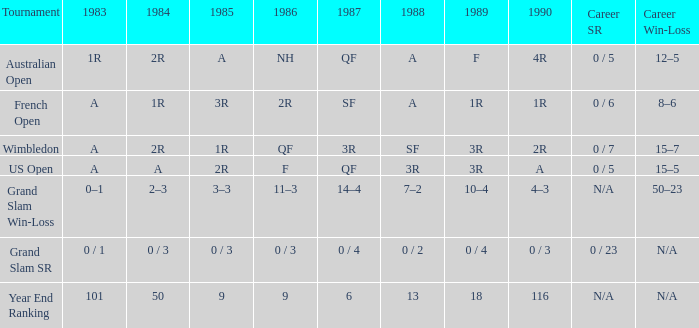In 1985, when the career win-loss is not available and the career sr is 0/23, what is the outcome? 0 / 3. 